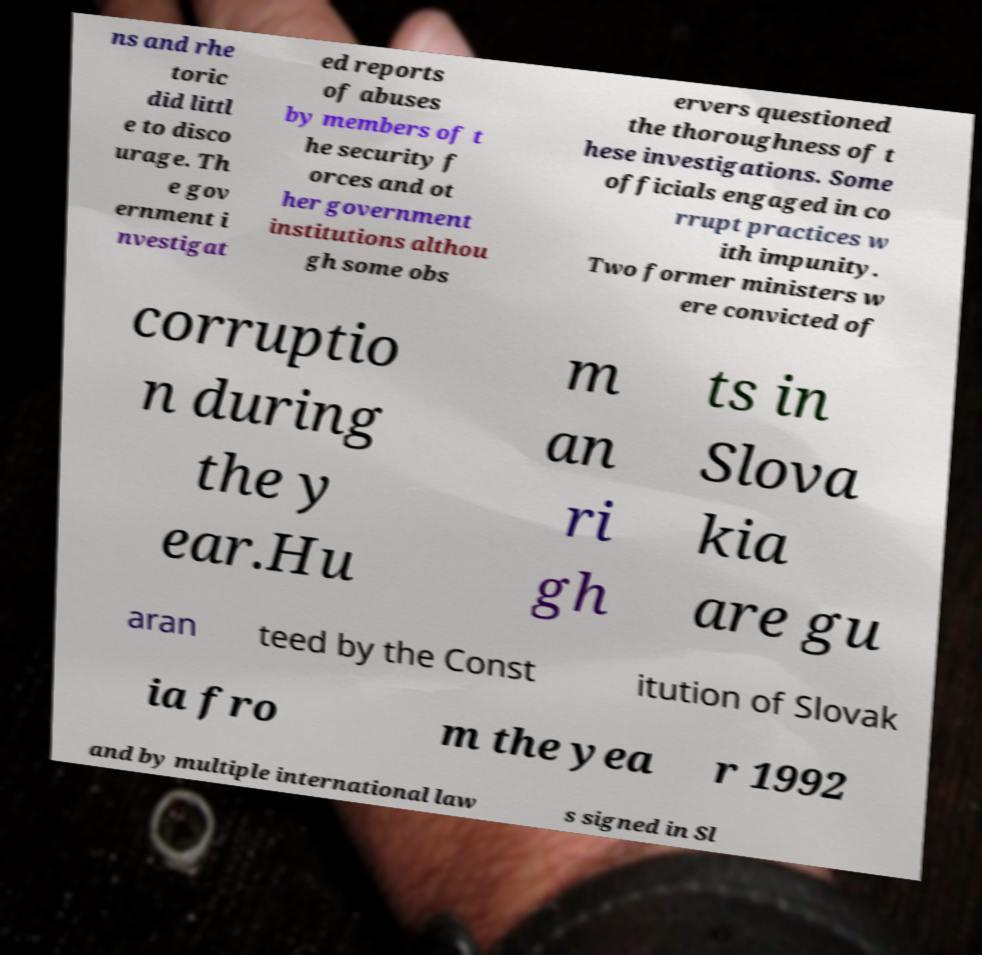Please read and relay the text visible in this image. What does it say? ns and rhe toric did littl e to disco urage. Th e gov ernment i nvestigat ed reports of abuses by members of t he security f orces and ot her government institutions althou gh some obs ervers questioned the thoroughness of t hese investigations. Some officials engaged in co rrupt practices w ith impunity. Two former ministers w ere convicted of corruptio n during the y ear.Hu m an ri gh ts in Slova kia are gu aran teed by the Const itution of Slovak ia fro m the yea r 1992 and by multiple international law s signed in Sl 